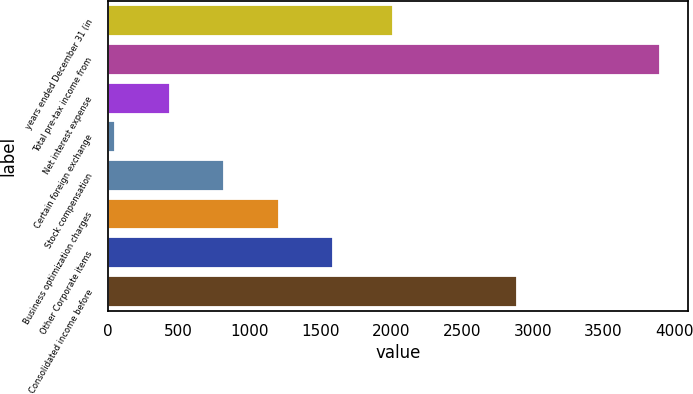<chart> <loc_0><loc_0><loc_500><loc_500><bar_chart><fcel>years ended December 31 (in<fcel>Total pre-tax income from<fcel>Net interest expense<fcel>Certain foreign exchange<fcel>Stock compensation<fcel>Business optimization charges<fcel>Other Corporate items<fcel>Consolidated income before<nl><fcel>2012<fcel>3901<fcel>437.8<fcel>53<fcel>822.6<fcel>1207.4<fcel>1592.2<fcel>2889<nl></chart> 